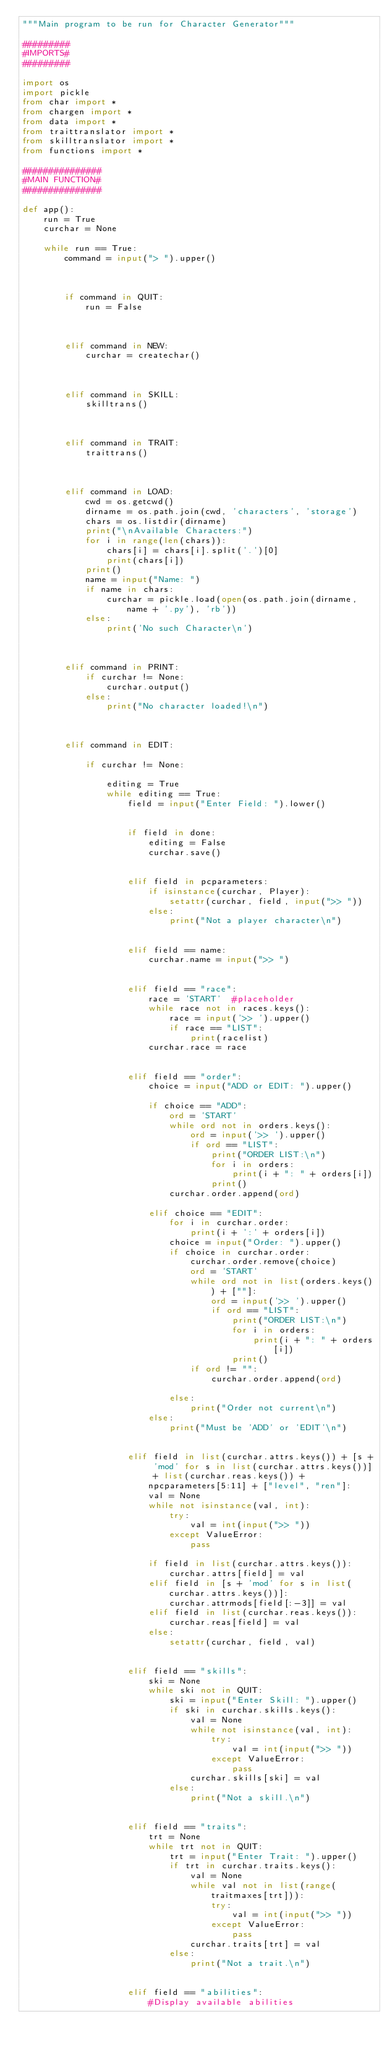<code> <loc_0><loc_0><loc_500><loc_500><_Python_>"""Main program to be run for Character Generator"""

#########
#IMPORTS#
#########

import os
import pickle
from char import *
from chargen import *
from data import *
from traittranslator import *
from skilltranslator import *
from functions import *

###############
#MAIN FUNCTION#
###############

def app():
    run = True
    curchar = None

    while run == True:
        command = input("> ").upper()



        if command in QUIT:
            run = False



        elif command in NEW:
            curchar = createchar()



        elif command in SKILL:
            skilltrans()



        elif command in TRAIT:
            traittrans()



        elif command in LOAD:
            cwd = os.getcwd()
            dirname = os.path.join(cwd, 'characters', 'storage')
            chars = os.listdir(dirname)
            print("\nAvailable Characters:")
            for i in range(len(chars)):
                chars[i] = chars[i].split('.')[0]
                print(chars[i])
            print()
            name = input("Name: ")
            if name in chars:
                curchar = pickle.load(open(os.path.join(dirname, name + '.py'), 'rb'))
            else:
                print('No such Character\n')



        elif command in PRINT:
            if curchar != None:
                curchar.output()
            else:
                print("No character loaded!\n")



        elif command in EDIT:

            if curchar != None:

                editing = True
                while editing == True:
                    field = input("Enter Field: ").lower()
                    

                    if field in done:
                        editing = False
                        curchar.save()
                    

                    elif field in pcparameters:
                        if isinstance(curchar, Player):
                            setattr(curchar, field, input(">> "))
                        else:
                            print("Not a player character\n")
                    

                    elif field == name:
                        curchar.name = input(">> ")
                    

                    elif field == "race":
                        race = 'START'	#placeholder
                        while race not in races.keys():
                            race = input('>> ').upper()
                            if race == "LIST":
                                print(racelist)
                        curchar.race = race
                    

                    elif field == "order":
                        choice = input("ADD or EDIT: ").upper()
                    
                        if choice == "ADD":
                            ord = 'START'
                            while ord not in orders.keys():
                                ord = input('>> ').upper()
                                if ord == "LIST":
                                    print("ORDER LIST:\n")
                                    for i in orders:
                                        print(i + ": " + orders[i])
                                    print()
                            curchar.order.append(ord)
                    
                        elif choice == "EDIT":
                            for i in curchar.order:
                                print(i + ':' + orders[i])
                            choice = input("Order: ").upper()
                            if choice in curchar.order:
                                curchar.order.remove(choice)
                                ord = 'START'
                                while ord not in list(orders.keys()) + [""]:
                                    ord = input('>> ').upper()
                                    if ord == "LIST":
                                        print("ORDER LIST:\n")
                                        for i in orders:
                                            print(i + ": " + orders[i])
                                        print()
                                if ord != "":
                                    curchar.order.append(ord)
                    
                            else:
                                print("Order not current\n")
                        else:
                            print("Must be 'ADD' or 'EDIT'\n")
                    
                    
                    elif field in list(curchar.attrs.keys()) + [s + 'mod' for s in list(curchar.attrs.keys())] + list(curchar.reas.keys()) + npcparameters[5:11] + ["level", "ren"]:
                        val = None
                        while not isinstance(val, int):
                            try:
                                val = int(input(">> "))
                            except ValueError:
                                pass

                        if field in list(curchar.attrs.keys()):
                            curchar.attrs[field] = val
                        elif field in [s + 'mod' for s in list(curchar.attrs.keys())]:
                            curchar.attrmods[field[:-3]] = val
                        elif field in list(curchar.reas.keys()):
                            curchar.reas[field] = val
                        else:
                            setattr(curchar, field, val)


                    elif field == "skills":
                        ski = None
                        while ski not in QUIT:
                            ski = input("Enter Skill: ").upper()
                            if ski in curchar.skills.keys():
                                val = None
                                while not isinstance(val, int):
                                    try:
                                        val = int(input(">> "))
                                    except ValueError:
                                        pass
                                curchar.skills[ski] = val
                            else:
                                print("Not a skill.\n")
                    

                    elif field == "traits":
                        trt = None
                        while trt not in QUIT:
                            trt = input("Enter Trait: ").upper()
                            if trt in curchar.traits.keys():
                                val = None
                                while val not in list(range(traitmaxes[trt])):
                                    try:
                                        val = int(input(">> "))
                                    except ValueError:
                                        pass
                                curchar.traits[trt] = val
                            else:
                                print("Not a trait.\n")


                    elif field == "abilities":
                        #Display available abilities</code> 